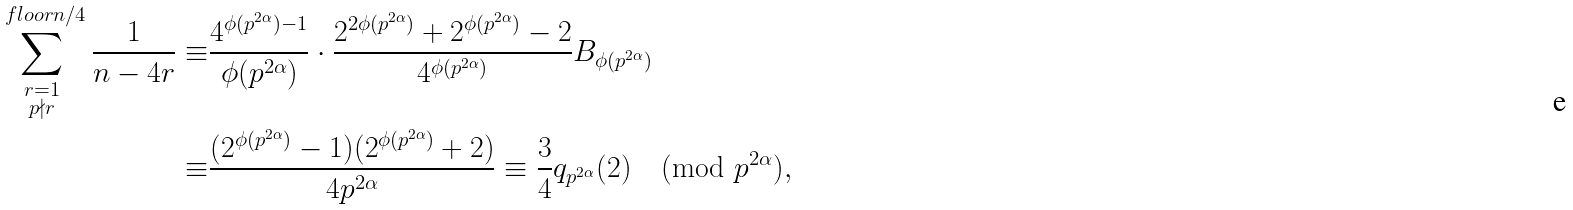<formula> <loc_0><loc_0><loc_500><loc_500>\sum _ { \substack { r = 1 \\ p \nmid r } } ^ { \ f l o o r { n / 4 } } \frac { 1 } { n - 4 r } \equiv & \frac { 4 ^ { \phi ( p ^ { 2 \alpha } ) - 1 } } { \phi ( p ^ { 2 \alpha } ) } \cdot \frac { 2 ^ { 2 \phi ( p ^ { 2 \alpha } ) } + 2 ^ { \phi ( p ^ { 2 \alpha } ) } - 2 } { 4 ^ { \phi ( p ^ { 2 \alpha } ) } } B _ { \phi ( p ^ { 2 \alpha } ) } \\ \equiv & \frac { ( 2 ^ { \phi ( p ^ { 2 \alpha } ) } - 1 ) ( 2 ^ { \phi ( p ^ { 2 \alpha } ) } + 2 ) } { 4 p ^ { 2 \alpha } } \equiv \frac { 3 } { 4 } q _ { p ^ { 2 \alpha } } ( 2 ) \pmod { p ^ { 2 \alpha } } ,</formula> 